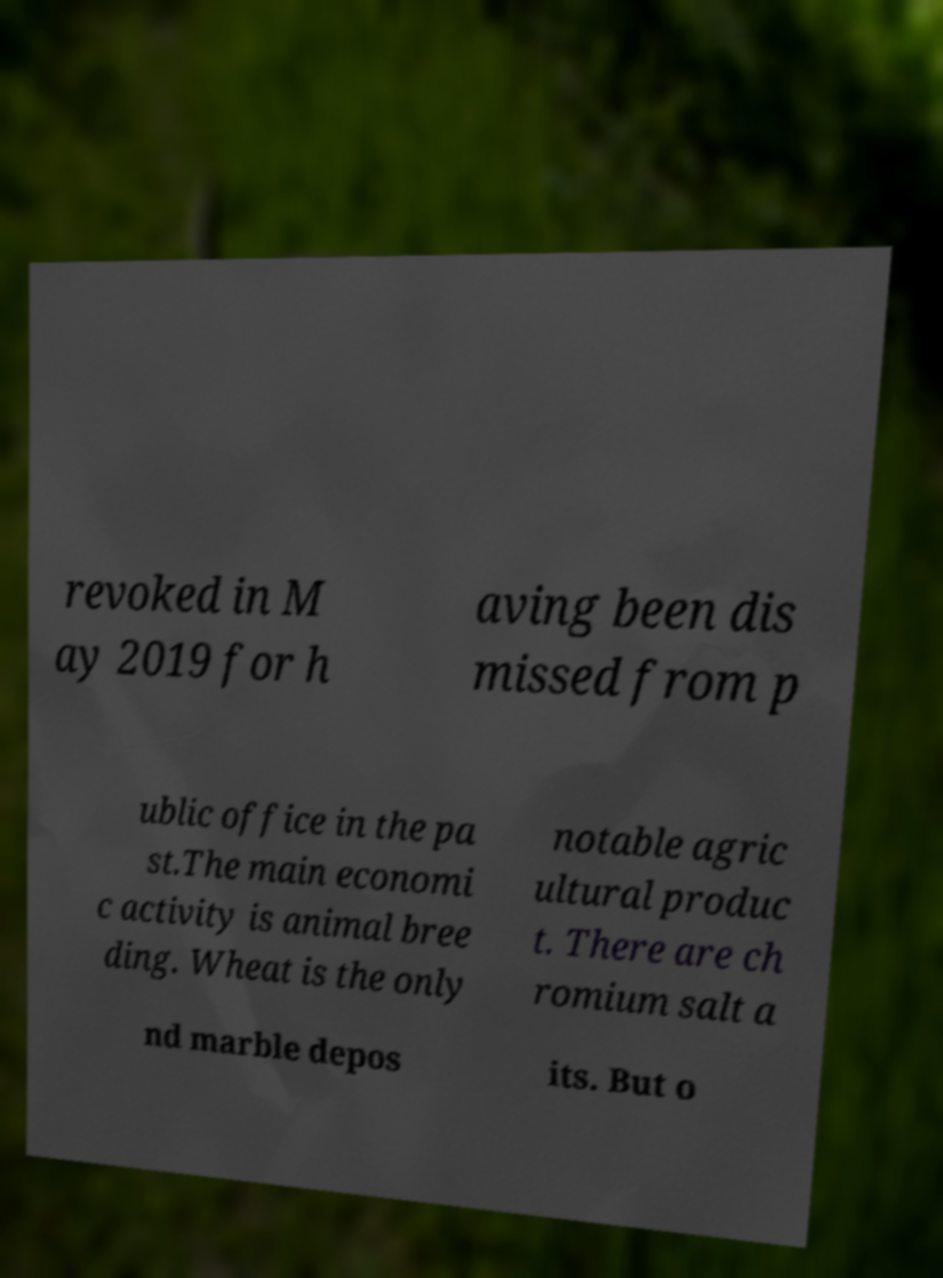Could you assist in decoding the text presented in this image and type it out clearly? revoked in M ay 2019 for h aving been dis missed from p ublic office in the pa st.The main economi c activity is animal bree ding. Wheat is the only notable agric ultural produc t. There are ch romium salt a nd marble depos its. But o 